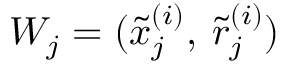Convert formula to latex. <formula><loc_0><loc_0><loc_500><loc_500>W _ { j } = ( \tilde { x } _ { j } ^ { ( i ) } , \, \tilde { r } _ { j } ^ { ( i ) } )</formula> 